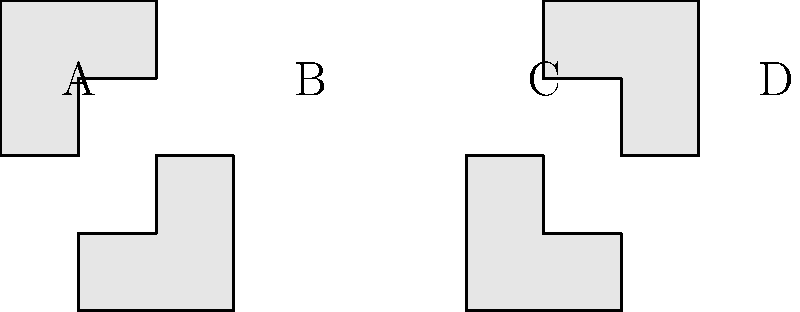As a beauty pageant contestant, you're asked to showcase your spatial intelligence. Which of the shapes B, C, or D is the correct mirror image of shape A when reflected across a vertical line? To solve this problem, let's follow these steps:

1. Understand mirror reflection: When an object is reflected across a vertical line, its left and right sides are swapped, but its top and bottom remain in the same relative positions.

2. Analyze shape A: It's an irregular polygon with a distinctive "L" shape on the left side and a rectangular protrusion on the top right.

3. Examine the options:
   B: This shape is rotated 180 degrees from A. It's not a mirror reflection.
   C: This shape is the correct mirror image of A. The "L" shape is now on the right side, and the rectangular protrusion is on the top left.
   D: This shape is A reflected across a horizontal line (flipped upside down). It's not a mirror reflection across a vertical line.

4. Verify C: If we imagine a vertical mirror line to the right of A, we can see that C is indeed the correct mirror image. All parts of the shape are correctly reversed left-to-right while maintaining their vertical positions.

Therefore, the correct mirror image of shape A when reflected across a vertical line is C.
Answer: C 